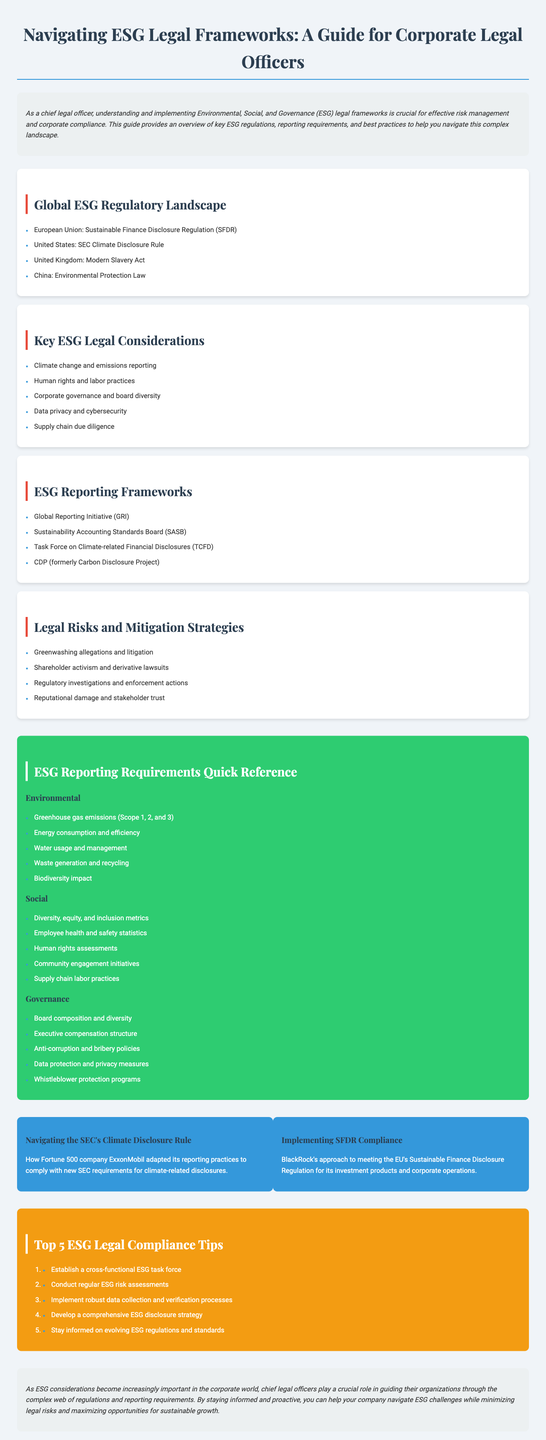What is the title of the brochure? The title of the brochure is prominently displayed at the top of the document.
Answer: Navigating ESG Legal Frameworks: A Guide for Corporate Legal Officers How many categories are in the ESG Reporting Requirements Quick Reference? The document lists the categories under the fold-out guide section.
Answer: 3 What regulation is mentioned for the United States? The document specifies key regulations for different regions under the Global ESG Regulatory Landscape section.
Answer: SEC Climate Disclosure Rule What does GRI stand for? The document lists various ESG reporting frameworks, including their acronyms.
Answer: Global Reporting Initiative Name one of the top ESG compliance tips. Essential compliance tips are provided in a dedicated section in the document.
Answer: Establish a cross-functional ESG task force What risk is associated with shareholder activism? The document outlines various legal risks associated with ESG practices.
Answer: Derivative lawsuits Which organization's approach to SFDR compliance is discussed in the case studies? The case studies section mentions specific companies that adapted to regulations.
Answer: BlackRock What is one requirement listed under the Social category? The fold-out guide provides specific requirements for each ESG category.
Answer: Diversity, equity, and inclusion metrics 